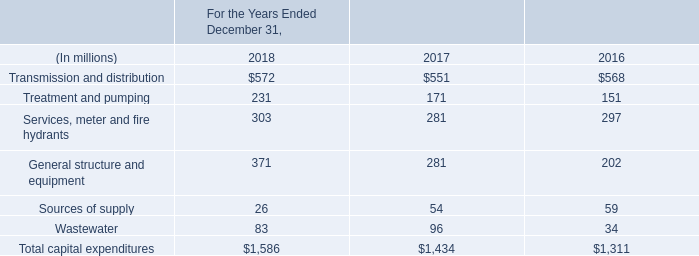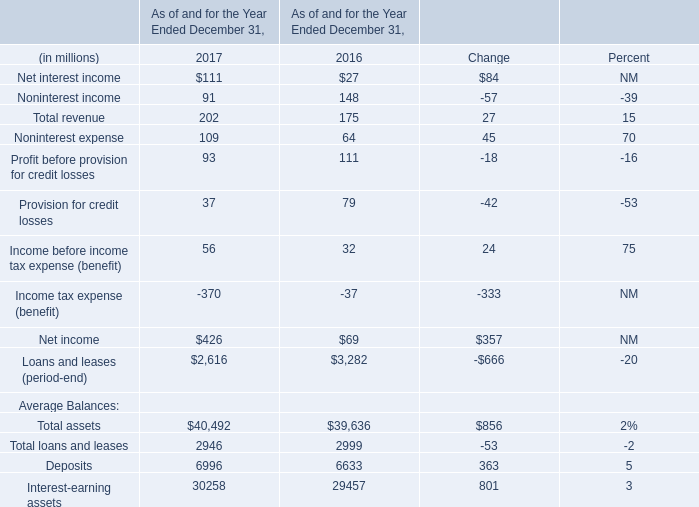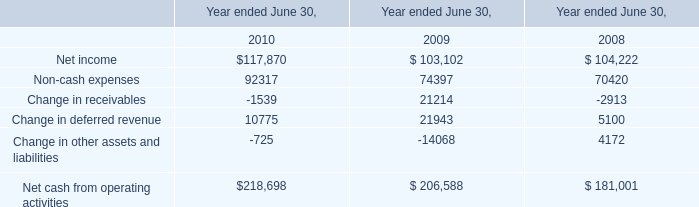What is the difference between the greatest total revenue in 2016 and 2017？ (in million) 
Computations: (202 - 175)
Answer: 27.0. 